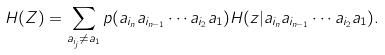Convert formula to latex. <formula><loc_0><loc_0><loc_500><loc_500>H ( Z ) = \sum _ { a _ { i _ { j } } \neq a _ { 1 } } p ( a _ { i _ { n } } a _ { i _ { n - 1 } } \cdots a _ { i _ { 2 } } a _ { 1 } ) H ( z | a _ { i _ { n } } a _ { i _ { n - 1 } } \cdots a _ { i _ { 2 } } a _ { 1 } ) .</formula> 